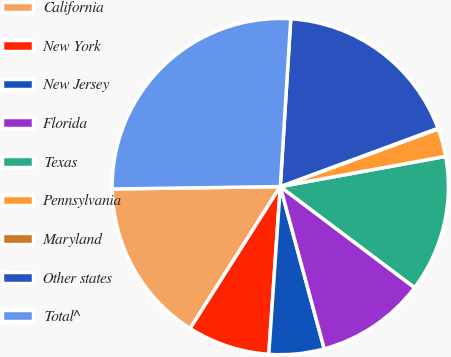Convert chart to OTSL. <chart><loc_0><loc_0><loc_500><loc_500><pie_chart><fcel>California<fcel>New York<fcel>New Jersey<fcel>Florida<fcel>Texas<fcel>Pennsylvania<fcel>Maryland<fcel>Other states<fcel>Total^<nl><fcel>15.76%<fcel>7.92%<fcel>5.3%<fcel>10.53%<fcel>13.14%<fcel>2.69%<fcel>0.07%<fcel>18.37%<fcel>26.22%<nl></chart> 